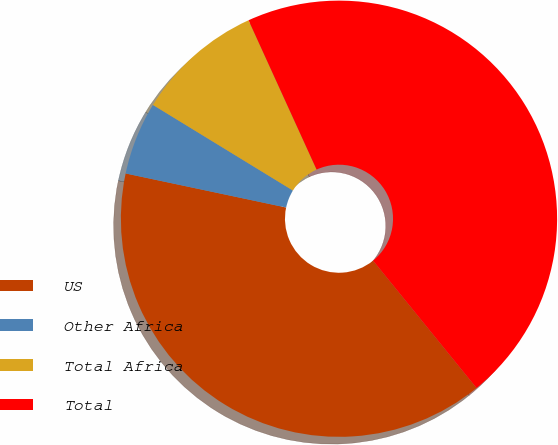Convert chart. <chart><loc_0><loc_0><loc_500><loc_500><pie_chart><fcel>US<fcel>Other Africa<fcel>Total Africa<fcel>Total<nl><fcel>39.19%<fcel>5.41%<fcel>9.46%<fcel>45.95%<nl></chart> 